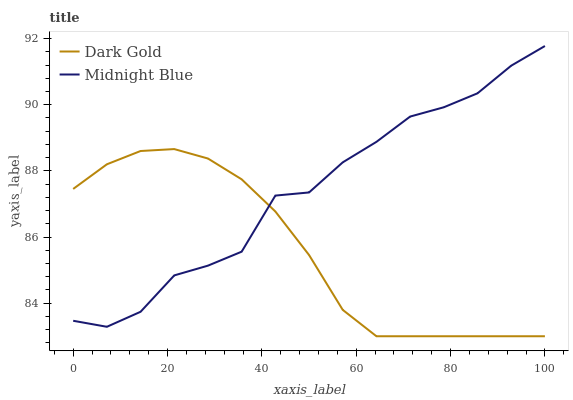Does Dark Gold have the minimum area under the curve?
Answer yes or no. Yes. Does Midnight Blue have the maximum area under the curve?
Answer yes or no. Yes. Does Dark Gold have the maximum area under the curve?
Answer yes or no. No. Is Dark Gold the smoothest?
Answer yes or no. Yes. Is Midnight Blue the roughest?
Answer yes or no. Yes. Is Dark Gold the roughest?
Answer yes or no. No. Does Dark Gold have the lowest value?
Answer yes or no. Yes. Does Midnight Blue have the highest value?
Answer yes or no. Yes. Does Dark Gold have the highest value?
Answer yes or no. No. Does Midnight Blue intersect Dark Gold?
Answer yes or no. Yes. Is Midnight Blue less than Dark Gold?
Answer yes or no. No. Is Midnight Blue greater than Dark Gold?
Answer yes or no. No. 